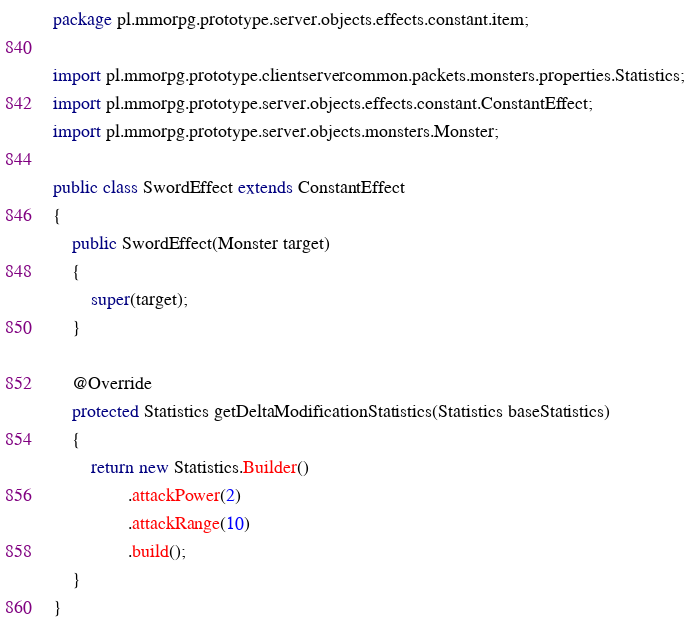<code> <loc_0><loc_0><loc_500><loc_500><_Java_>package pl.mmorpg.prototype.server.objects.effects.constant.item;

import pl.mmorpg.prototype.clientservercommon.packets.monsters.properties.Statistics;
import pl.mmorpg.prototype.server.objects.effects.constant.ConstantEffect;
import pl.mmorpg.prototype.server.objects.monsters.Monster;

public class SwordEffect extends ConstantEffect
{
	public SwordEffect(Monster target)
	{
		super(target);
	}

	@Override
	protected Statistics getDeltaModificationStatistics(Statistics baseStatistics)
	{
		return new Statistics.Builder()
				.attackPower(2)
				.attackRange(10)
				.build();
	}
}
</code> 